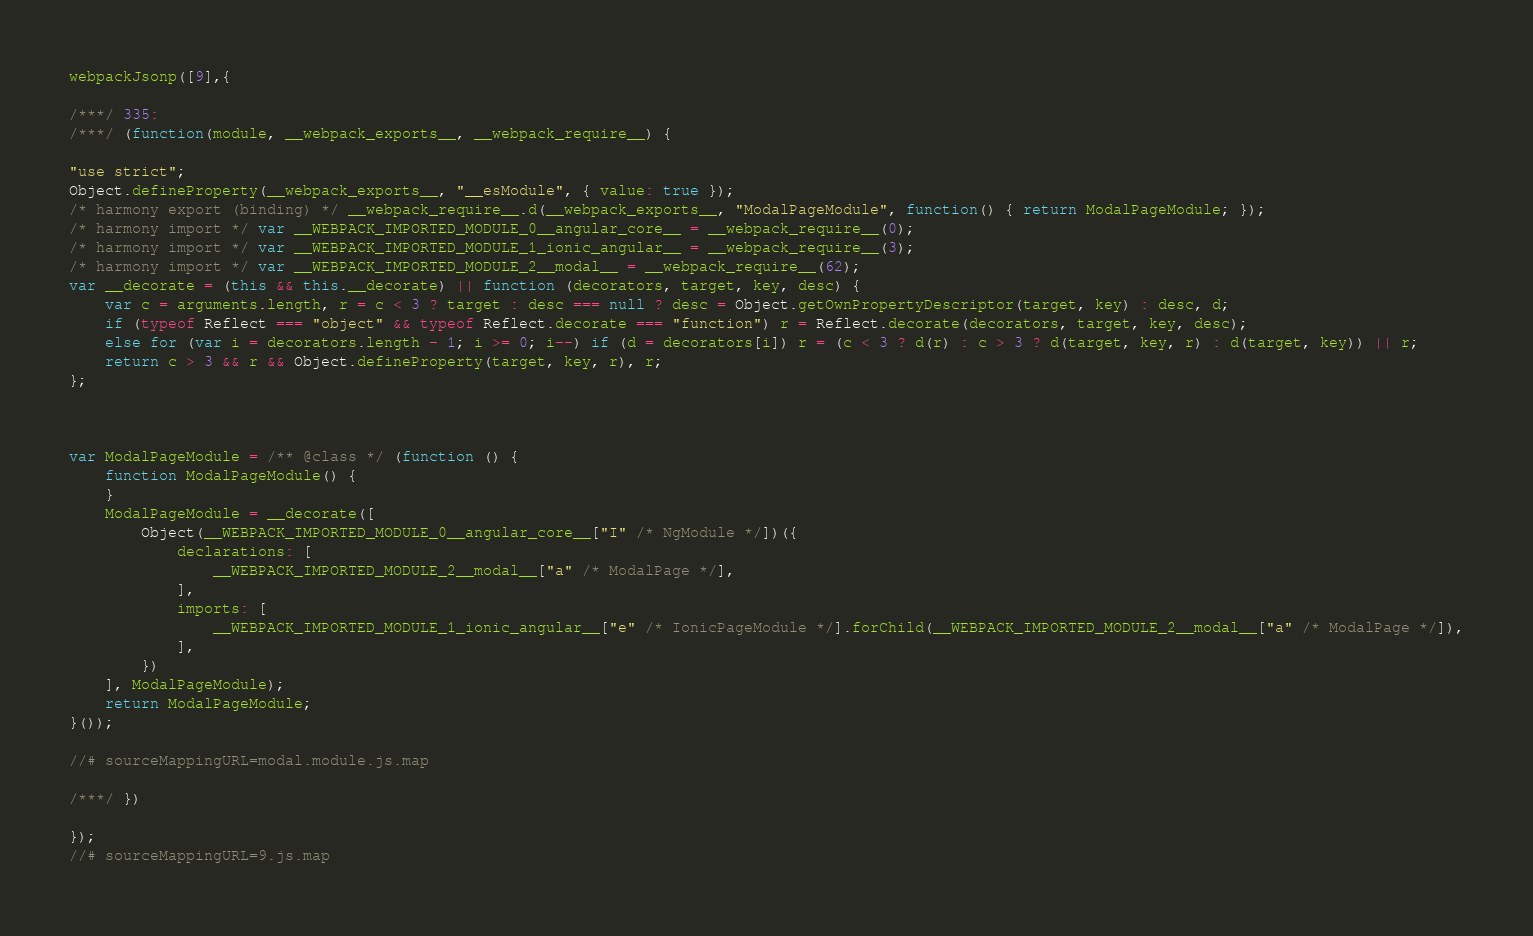<code> <loc_0><loc_0><loc_500><loc_500><_JavaScript_>webpackJsonp([9],{

/***/ 335:
/***/ (function(module, __webpack_exports__, __webpack_require__) {

"use strict";
Object.defineProperty(__webpack_exports__, "__esModule", { value: true });
/* harmony export (binding) */ __webpack_require__.d(__webpack_exports__, "ModalPageModule", function() { return ModalPageModule; });
/* harmony import */ var __WEBPACK_IMPORTED_MODULE_0__angular_core__ = __webpack_require__(0);
/* harmony import */ var __WEBPACK_IMPORTED_MODULE_1_ionic_angular__ = __webpack_require__(3);
/* harmony import */ var __WEBPACK_IMPORTED_MODULE_2__modal__ = __webpack_require__(62);
var __decorate = (this && this.__decorate) || function (decorators, target, key, desc) {
    var c = arguments.length, r = c < 3 ? target : desc === null ? desc = Object.getOwnPropertyDescriptor(target, key) : desc, d;
    if (typeof Reflect === "object" && typeof Reflect.decorate === "function") r = Reflect.decorate(decorators, target, key, desc);
    else for (var i = decorators.length - 1; i >= 0; i--) if (d = decorators[i]) r = (c < 3 ? d(r) : c > 3 ? d(target, key, r) : d(target, key)) || r;
    return c > 3 && r && Object.defineProperty(target, key, r), r;
};



var ModalPageModule = /** @class */ (function () {
    function ModalPageModule() {
    }
    ModalPageModule = __decorate([
        Object(__WEBPACK_IMPORTED_MODULE_0__angular_core__["I" /* NgModule */])({
            declarations: [
                __WEBPACK_IMPORTED_MODULE_2__modal__["a" /* ModalPage */],
            ],
            imports: [
                __WEBPACK_IMPORTED_MODULE_1_ionic_angular__["e" /* IonicPageModule */].forChild(__WEBPACK_IMPORTED_MODULE_2__modal__["a" /* ModalPage */]),
            ],
        })
    ], ModalPageModule);
    return ModalPageModule;
}());

//# sourceMappingURL=modal.module.js.map

/***/ })

});
//# sourceMappingURL=9.js.map</code> 